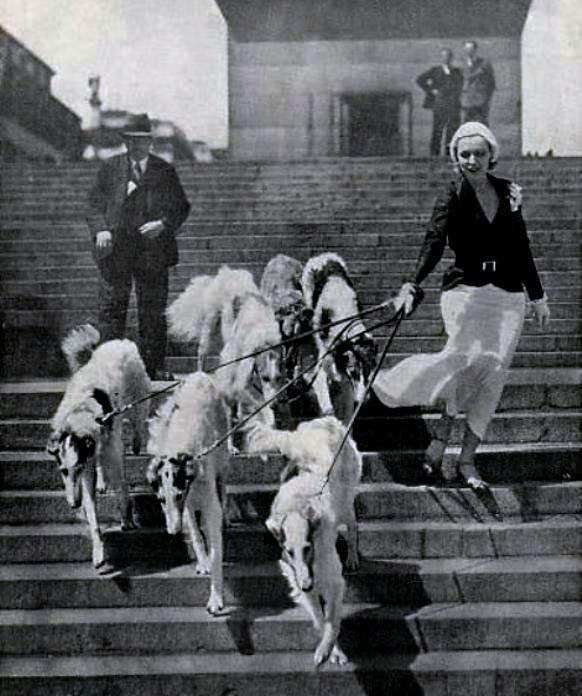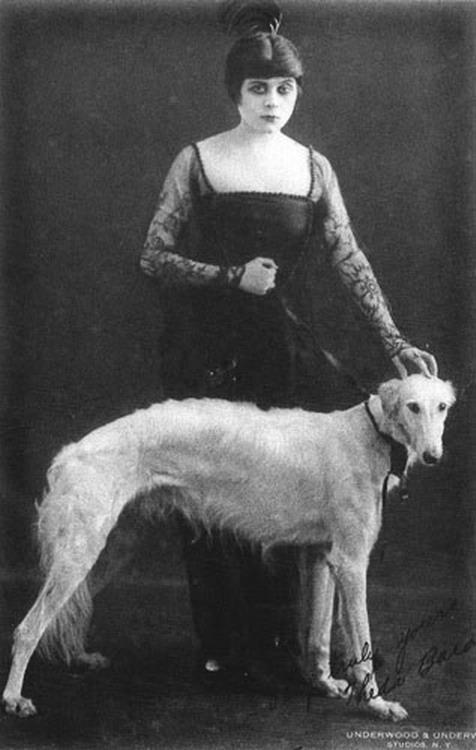The first image is the image on the left, the second image is the image on the right. Examine the images to the left and right. Is the description "In one image, afghans are on leashes, and a man is on the left of a woman in a blowing skirt." accurate? Answer yes or no. Yes. The first image is the image on the left, the second image is the image on the right. Examine the images to the left and right. Is the description "There are three people and three dogs." accurate? Answer yes or no. No. 